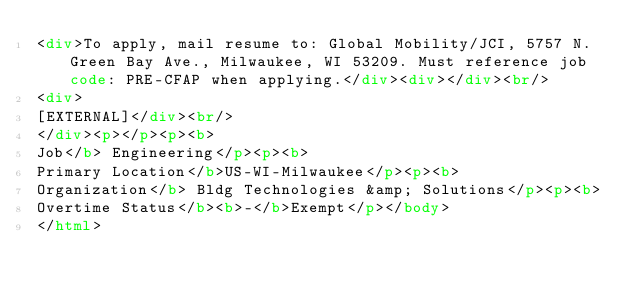<code> <loc_0><loc_0><loc_500><loc_500><_HTML_><div>To apply, mail resume to: Global Mobility/JCI, 5757 N. Green Bay Ave., Milwaukee, WI 53209. Must reference job code: PRE-CFAP when applying.</div><div></div><br/>
<div>
[EXTERNAL]</div><br/>
</div><p></p><p><b>
Job</b> Engineering</p><p><b>
Primary Location</b>US-WI-Milwaukee</p><p><b>
Organization</b> Bldg Technologies &amp; Solutions</p><p><b>
Overtime Status</b><b>-</b>Exempt</p></body>
</html></code> 